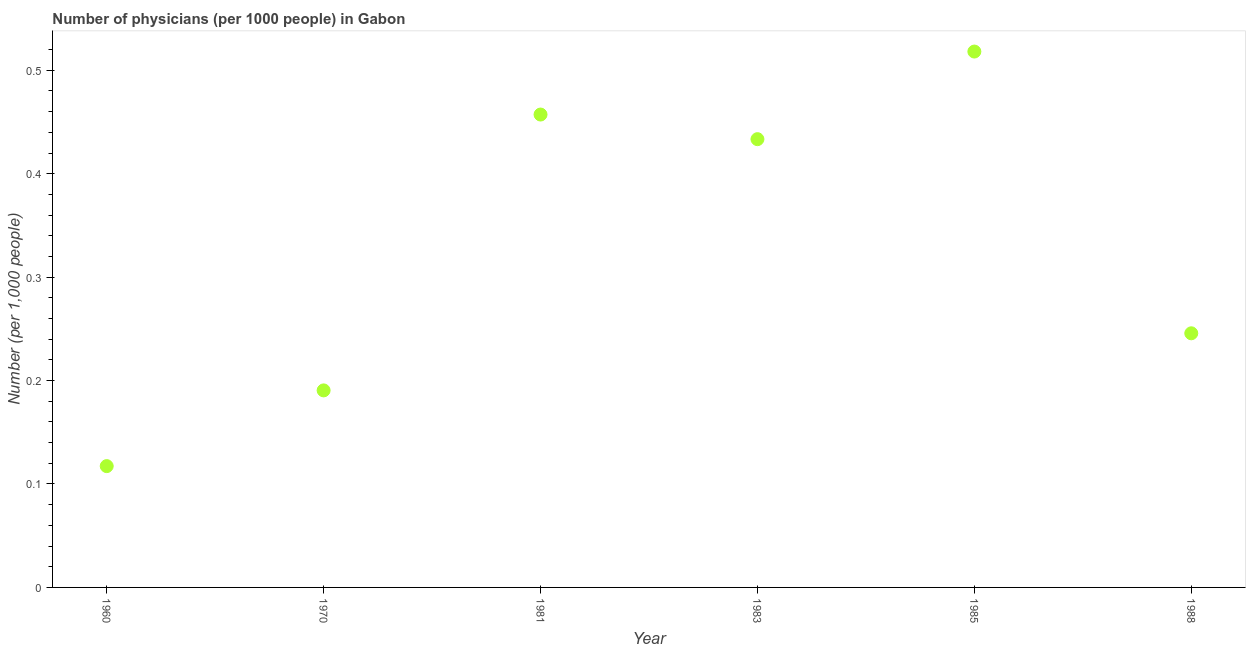What is the number of physicians in 1988?
Give a very brief answer. 0.25. Across all years, what is the maximum number of physicians?
Offer a terse response. 0.52. Across all years, what is the minimum number of physicians?
Offer a very short reply. 0.12. What is the sum of the number of physicians?
Give a very brief answer. 1.96. What is the difference between the number of physicians in 1983 and 1985?
Your response must be concise. -0.08. What is the average number of physicians per year?
Your answer should be very brief. 0.33. What is the median number of physicians?
Your answer should be compact. 0.34. In how many years, is the number of physicians greater than 0.4 ?
Your response must be concise. 3. Do a majority of the years between 1983 and 1988 (inclusive) have number of physicians greater than 0.26 ?
Ensure brevity in your answer.  Yes. What is the ratio of the number of physicians in 1960 to that in 1983?
Offer a very short reply. 0.27. Is the number of physicians in 1981 less than that in 1988?
Your answer should be compact. No. What is the difference between the highest and the second highest number of physicians?
Provide a short and direct response. 0.06. Is the sum of the number of physicians in 1970 and 1988 greater than the maximum number of physicians across all years?
Your answer should be very brief. No. What is the difference between the highest and the lowest number of physicians?
Your response must be concise. 0.4. In how many years, is the number of physicians greater than the average number of physicians taken over all years?
Provide a short and direct response. 3. How many years are there in the graph?
Your answer should be very brief. 6. Are the values on the major ticks of Y-axis written in scientific E-notation?
Make the answer very short. No. Does the graph contain grids?
Your answer should be very brief. No. What is the title of the graph?
Your response must be concise. Number of physicians (per 1000 people) in Gabon. What is the label or title of the Y-axis?
Give a very brief answer. Number (per 1,0 people). What is the Number (per 1,000 people) in 1960?
Ensure brevity in your answer.  0.12. What is the Number (per 1,000 people) in 1970?
Offer a very short reply. 0.19. What is the Number (per 1,000 people) in 1981?
Make the answer very short. 0.46. What is the Number (per 1,000 people) in 1983?
Your response must be concise. 0.43. What is the Number (per 1,000 people) in 1985?
Provide a short and direct response. 0.52. What is the Number (per 1,000 people) in 1988?
Give a very brief answer. 0.25. What is the difference between the Number (per 1,000 people) in 1960 and 1970?
Make the answer very short. -0.07. What is the difference between the Number (per 1,000 people) in 1960 and 1981?
Your answer should be very brief. -0.34. What is the difference between the Number (per 1,000 people) in 1960 and 1983?
Provide a succinct answer. -0.32. What is the difference between the Number (per 1,000 people) in 1960 and 1985?
Your response must be concise. -0.4. What is the difference between the Number (per 1,000 people) in 1960 and 1988?
Your response must be concise. -0.13. What is the difference between the Number (per 1,000 people) in 1970 and 1981?
Offer a very short reply. -0.27. What is the difference between the Number (per 1,000 people) in 1970 and 1983?
Offer a terse response. -0.24. What is the difference between the Number (per 1,000 people) in 1970 and 1985?
Your response must be concise. -0.33. What is the difference between the Number (per 1,000 people) in 1970 and 1988?
Provide a short and direct response. -0.06. What is the difference between the Number (per 1,000 people) in 1981 and 1983?
Offer a very short reply. 0.02. What is the difference between the Number (per 1,000 people) in 1981 and 1985?
Offer a very short reply. -0.06. What is the difference between the Number (per 1,000 people) in 1981 and 1988?
Give a very brief answer. 0.21. What is the difference between the Number (per 1,000 people) in 1983 and 1985?
Your answer should be compact. -0.08. What is the difference between the Number (per 1,000 people) in 1983 and 1988?
Provide a succinct answer. 0.19. What is the difference between the Number (per 1,000 people) in 1985 and 1988?
Provide a succinct answer. 0.27. What is the ratio of the Number (per 1,000 people) in 1960 to that in 1970?
Make the answer very short. 0.62. What is the ratio of the Number (per 1,000 people) in 1960 to that in 1981?
Your response must be concise. 0.26. What is the ratio of the Number (per 1,000 people) in 1960 to that in 1983?
Make the answer very short. 0.27. What is the ratio of the Number (per 1,000 people) in 1960 to that in 1985?
Your answer should be compact. 0.23. What is the ratio of the Number (per 1,000 people) in 1960 to that in 1988?
Provide a succinct answer. 0.48. What is the ratio of the Number (per 1,000 people) in 1970 to that in 1981?
Provide a succinct answer. 0.42. What is the ratio of the Number (per 1,000 people) in 1970 to that in 1983?
Your answer should be very brief. 0.44. What is the ratio of the Number (per 1,000 people) in 1970 to that in 1985?
Make the answer very short. 0.37. What is the ratio of the Number (per 1,000 people) in 1970 to that in 1988?
Make the answer very short. 0.78. What is the ratio of the Number (per 1,000 people) in 1981 to that in 1983?
Offer a very short reply. 1.05. What is the ratio of the Number (per 1,000 people) in 1981 to that in 1985?
Your answer should be compact. 0.88. What is the ratio of the Number (per 1,000 people) in 1981 to that in 1988?
Ensure brevity in your answer.  1.86. What is the ratio of the Number (per 1,000 people) in 1983 to that in 1985?
Your answer should be compact. 0.84. What is the ratio of the Number (per 1,000 people) in 1983 to that in 1988?
Provide a succinct answer. 1.76. What is the ratio of the Number (per 1,000 people) in 1985 to that in 1988?
Your answer should be very brief. 2.11. 